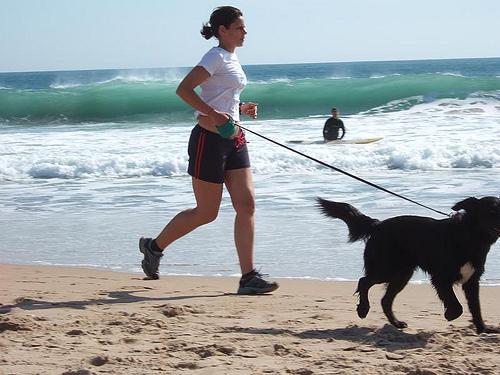What is the woman walking the dog wearing?
Quick response, please. Shorts. How many people are shown?
Answer briefly. 2. What is the man in the water doing?
Write a very short answer. Surfing. 